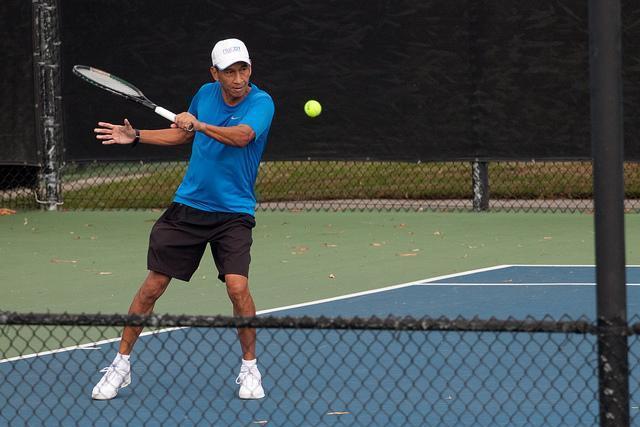How many kites are flying?
Give a very brief answer. 0. 